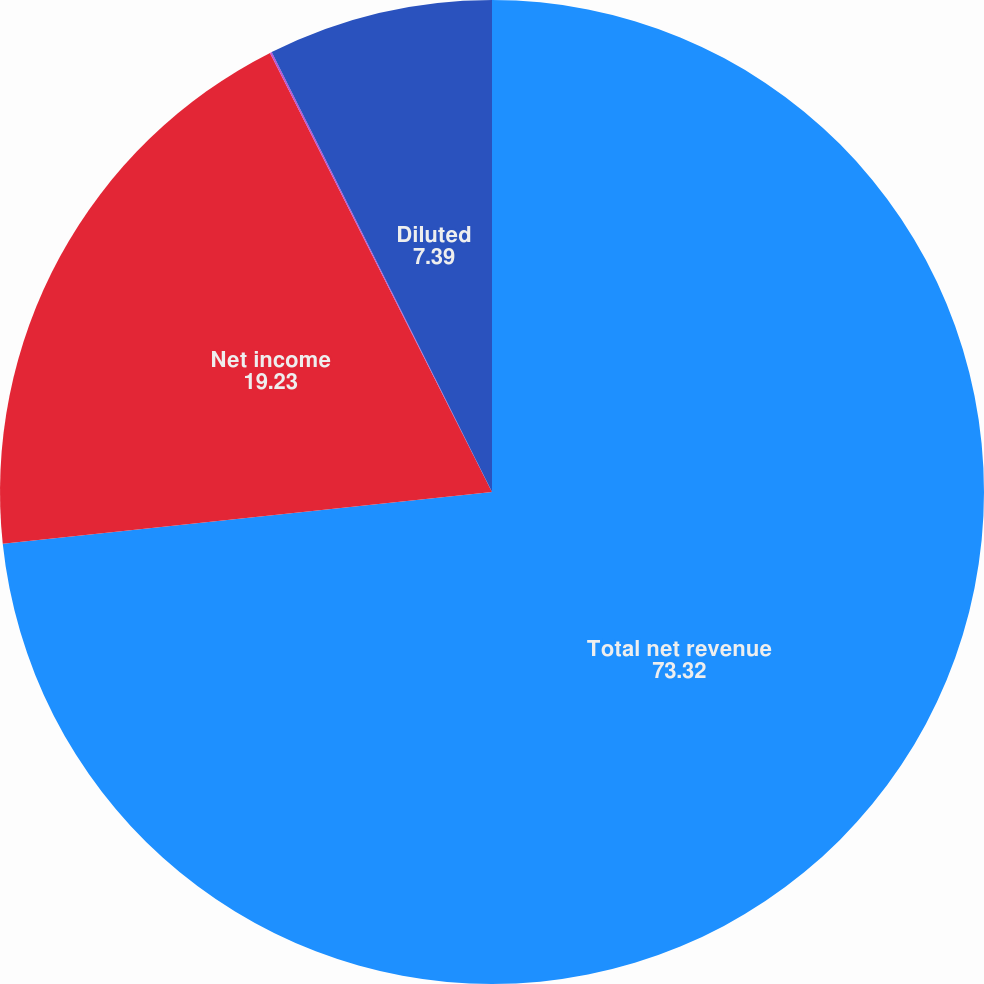Convert chart. <chart><loc_0><loc_0><loc_500><loc_500><pie_chart><fcel>Total net revenue<fcel>Net income<fcel>Basic<fcel>Diluted<nl><fcel>73.32%<fcel>19.23%<fcel>0.06%<fcel>7.39%<nl></chart> 